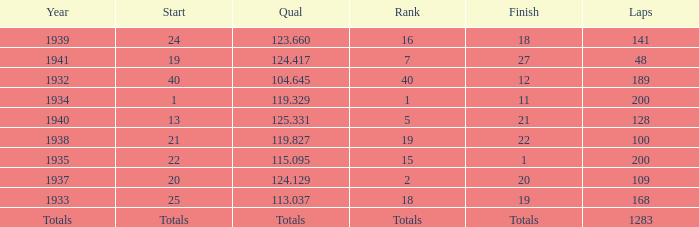What was the rank with the qual of 115.095? 15.0. 